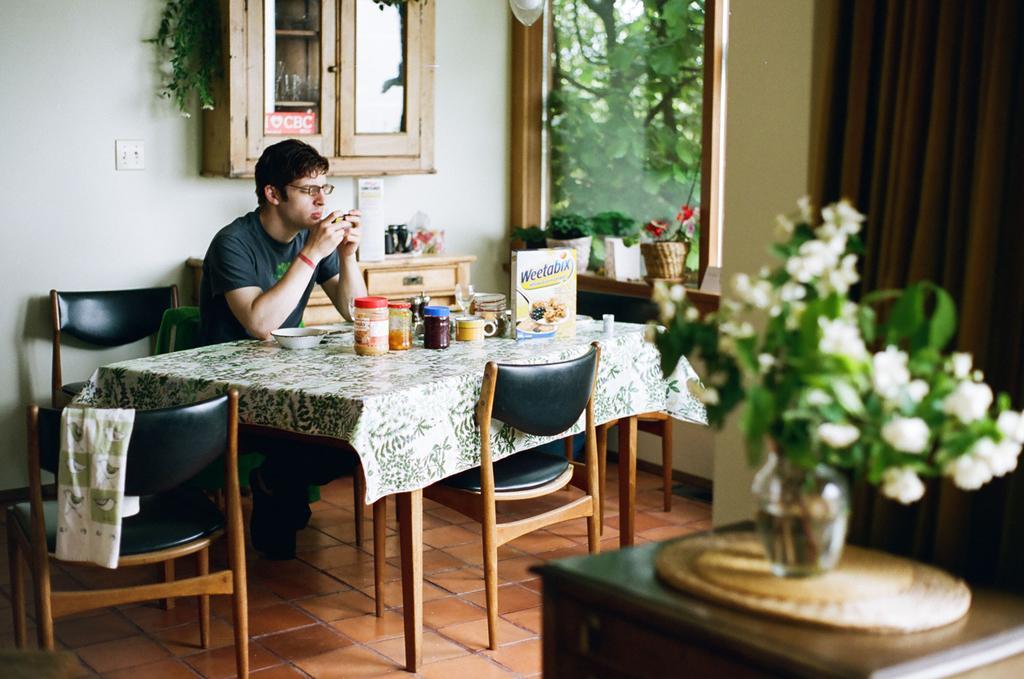Could you give a brief overview of what you see in this image? In this image there is a person sitting on the dining table operating a phone and at the right side of the image there is a flower bouquet and at the top of the image there is a glass door and window 